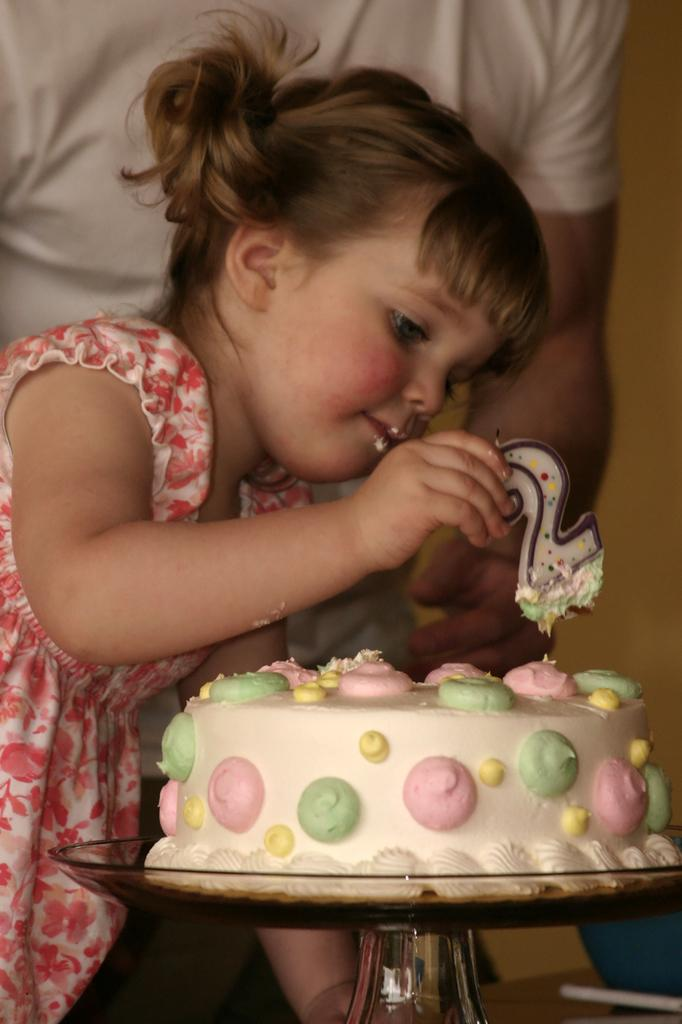Who can be seen in the image? There are people in the image. Can you describe the girl's position in the image? There is a girl on the left side of the image. What object is in front of the girl? There is a cake in front of the girl. What is the girl holding in the image? The girl is holding a candle. What type of quartz can be seen in the girl's hand in the image? There is no quartz present in the image; the girl is holding a candle. 